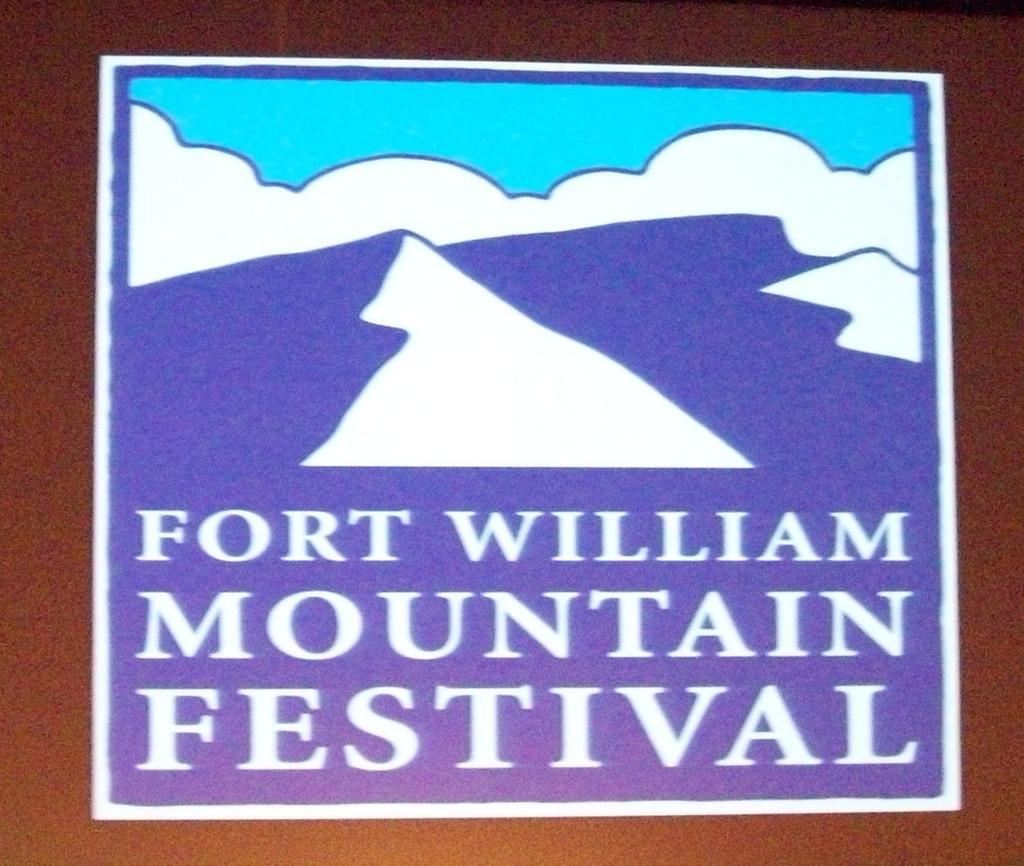<image>
Relay a brief, clear account of the picture shown. A blue and white poster for Fort William Mountain Festival. 